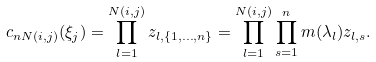Convert formula to latex. <formula><loc_0><loc_0><loc_500><loc_500>c _ { n N ( i , j ) } ( \xi _ { j } ) = \prod _ { l = 1 } ^ { N ( i , j ) } z _ { l , \{ 1 , \dots , n \} } = \prod _ { l = 1 } ^ { N ( i , j ) } \prod _ { s = 1 } ^ { n } m ( \lambda _ { l } ) z _ { l , s } .</formula> 